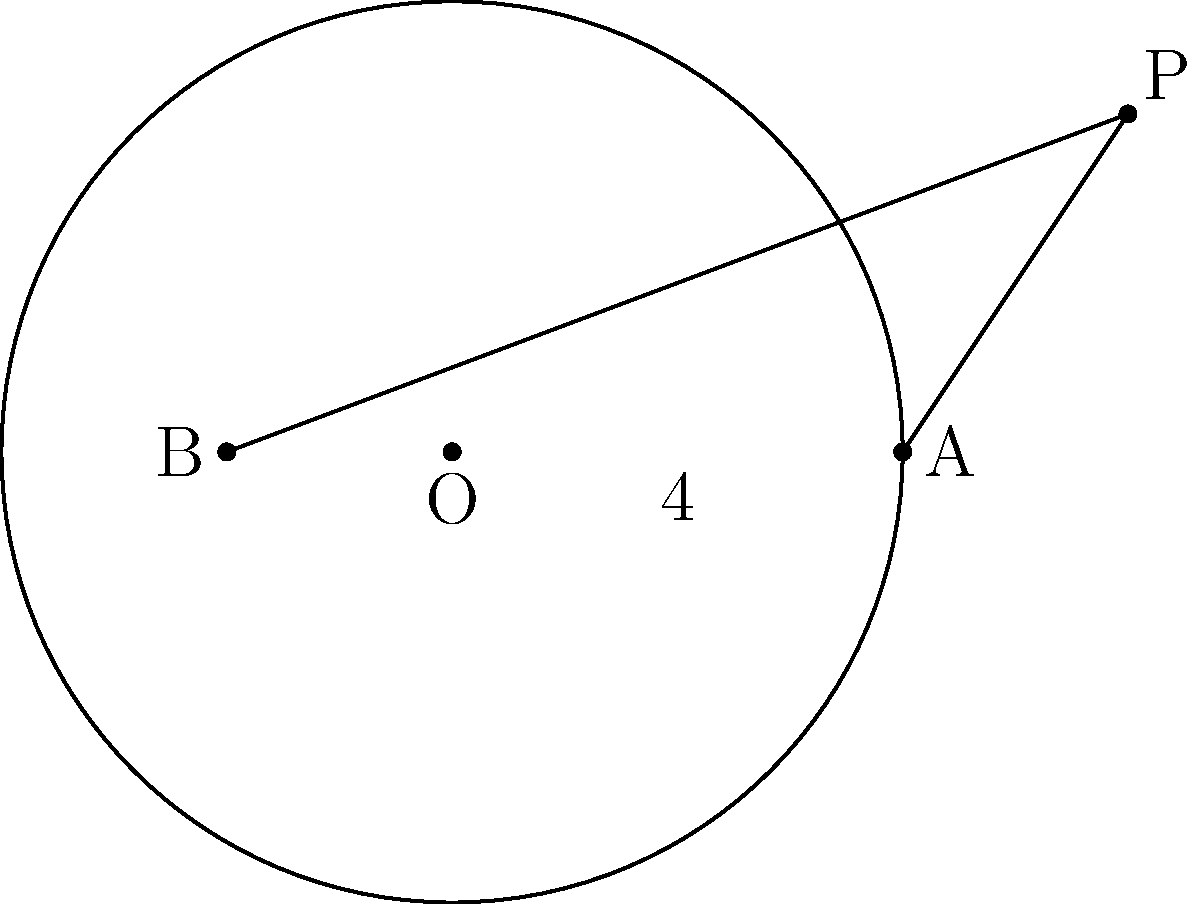In the diagram, point P is external to the circle with center O and radius 4 units. PA is tangent to the circle at A, and PB is a secant intersecting the circle at two points. If PB = 8 units and the length of the chord formed by PB is 4 units, what is the length of PA? Let's approach this step-by-step using the tangent-secant theorem:

1) The tangent-secant theorem states that for an external point P, a tangent PA, and a secant PB:

   $$(PA)^2 = PB \cdot PC$$

   where C is the other point where PB intersects the circle.

2) We're given that PB = 8 units and the chord length is 4 units.

3) Let's call the chord length BC. We know that:

   $$PB - PC = BC = 4$$

4) Since PB = 8, we can find PC:

   $$PC = PB - BC = 8 - 4 = 4$$

5) Now we can apply the tangent-secant theorem:

   $$(PA)^2 = PB \cdot PC = 8 \cdot 4 = 32$$

6) To find PA, we take the square root of both sides:

   $$PA = \sqrt{32} = 4\sqrt{2}$$

This result, $4\sqrt{2}$, is significant in military operations, representing the diagonal of a 4x4 square, which could be useful in tactical positioning or movement calculations.
Answer: $4\sqrt{2}$ units 